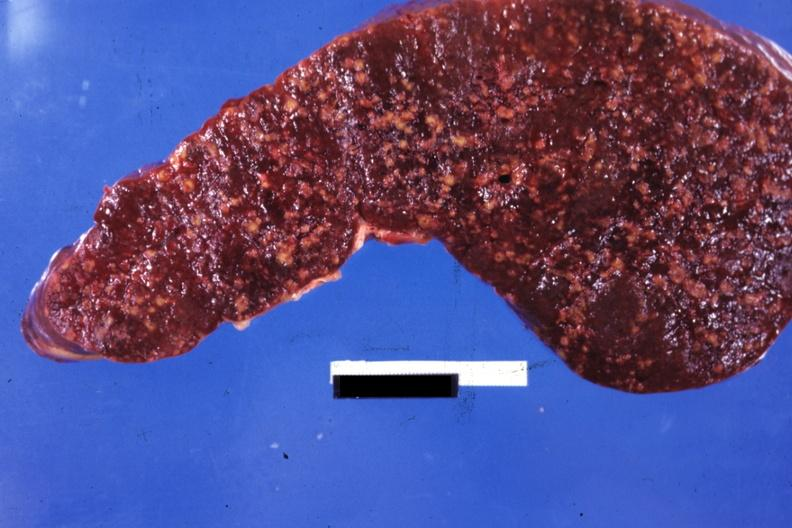what is present?
Answer the question using a single word or phrase. Hematologic 